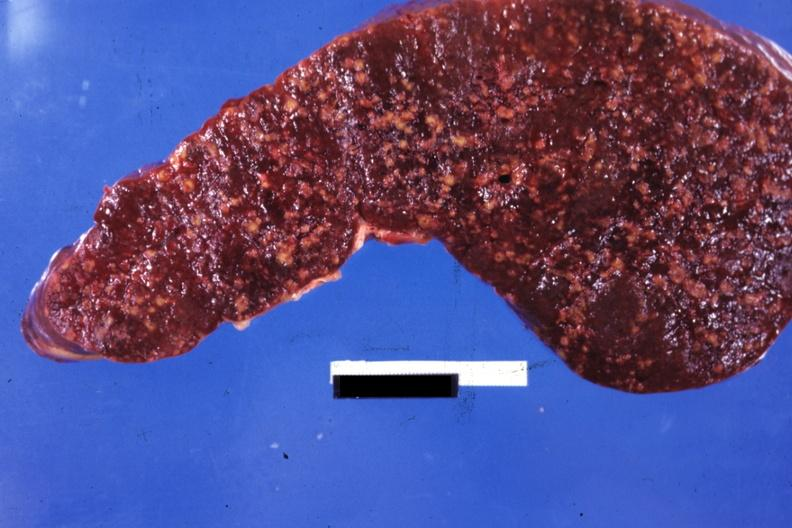what is present?
Answer the question using a single word or phrase. Hematologic 